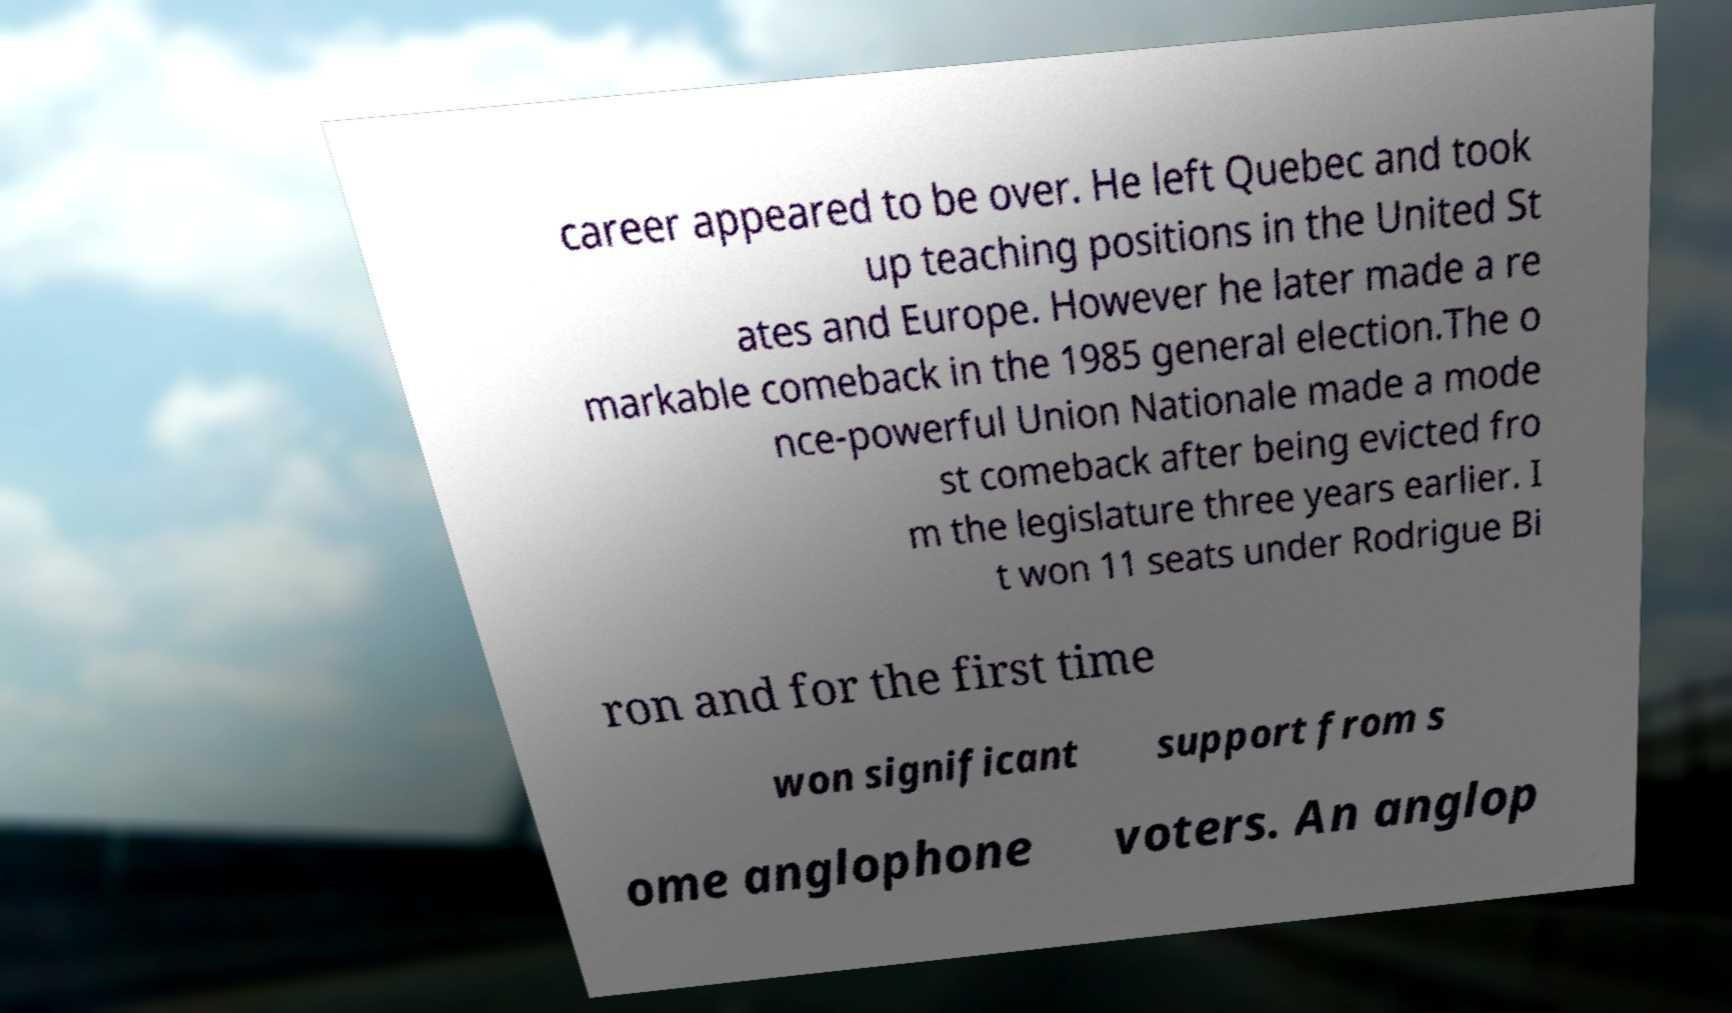Could you assist in decoding the text presented in this image and type it out clearly? career appeared to be over. He left Quebec and took up teaching positions in the United St ates and Europe. However he later made a re markable comeback in the 1985 general election.The o nce-powerful Union Nationale made a mode st comeback after being evicted fro m the legislature three years earlier. I t won 11 seats under Rodrigue Bi ron and for the first time won significant support from s ome anglophone voters. An anglop 